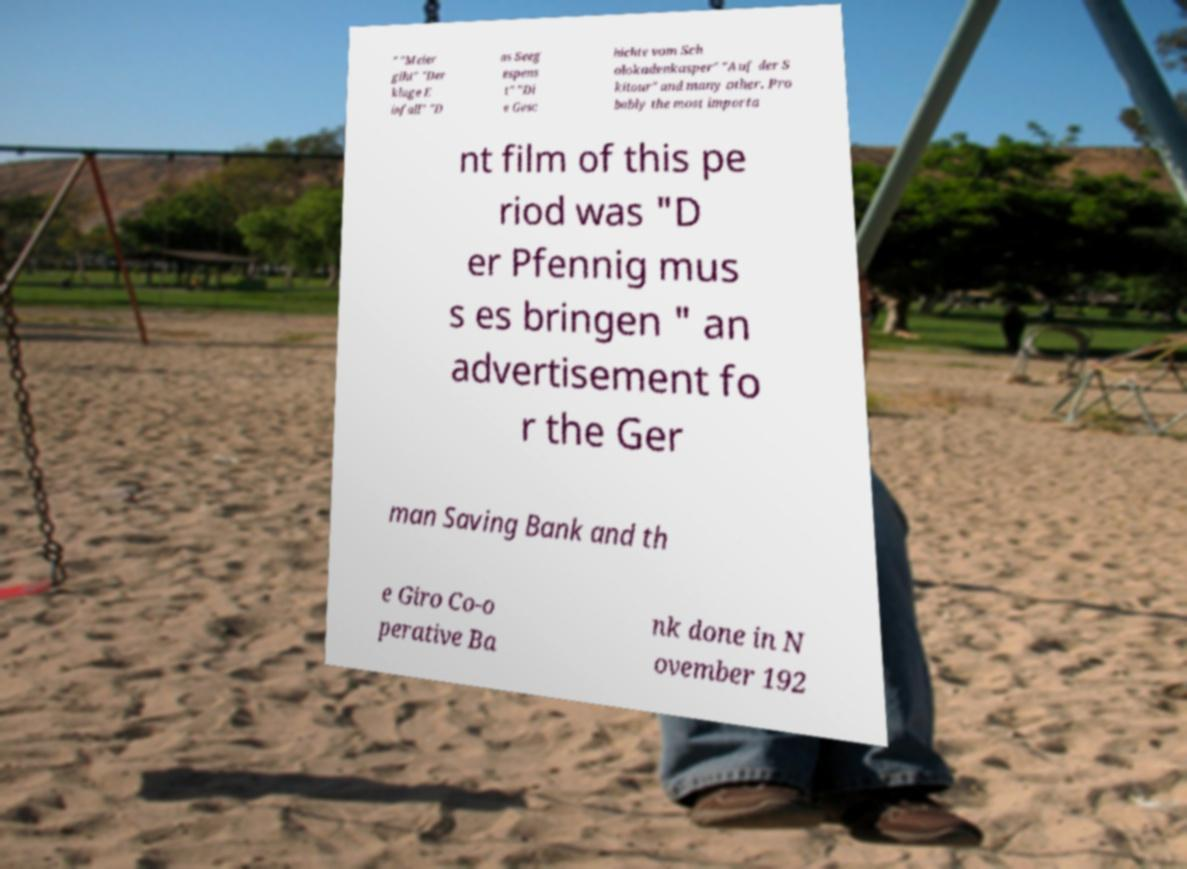What messages or text are displayed in this image? I need them in a readable, typed format. " "Meier glht" "Der kluge E infall" "D as Seeg espens t" "Di e Gesc hichte vom Sch olokadenkasper" "Auf der S kitour" and many other. Pro bably the most importa nt film of this pe riod was "D er Pfennig mus s es bringen " an advertisement fo r the Ger man Saving Bank and th e Giro Co-o perative Ba nk done in N ovember 192 